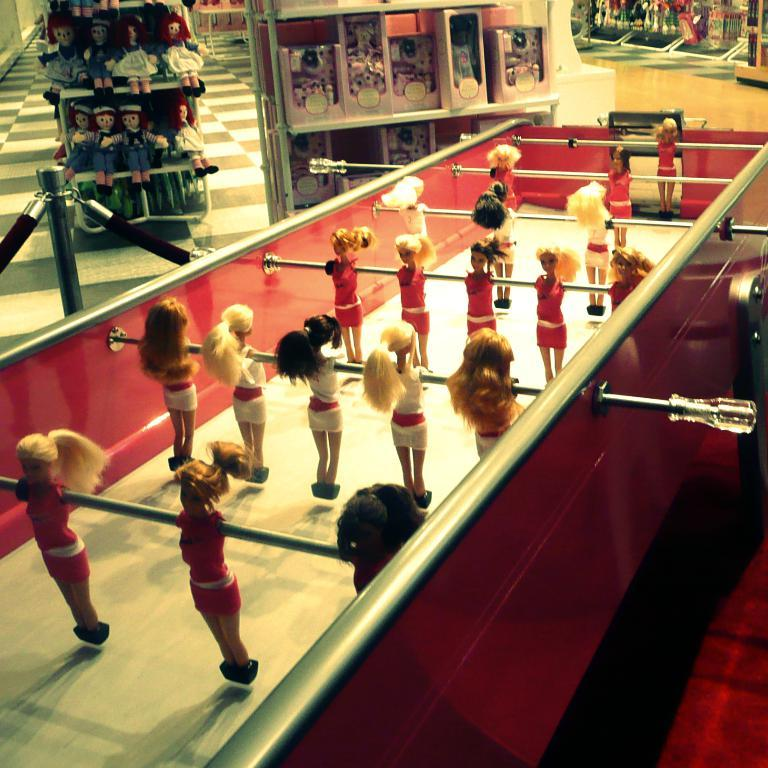What type of game can be seen in the image? There is a table top football table in the image. What color is the table top football table? The table top football table is colored red. What other objects are visible in the image? There are dolls in the top left of the image. What type of flooring is visible beneath the table top football table in the image? The provided facts do not mention the flooring beneath the table top football table, so it cannot be determined from the image. 